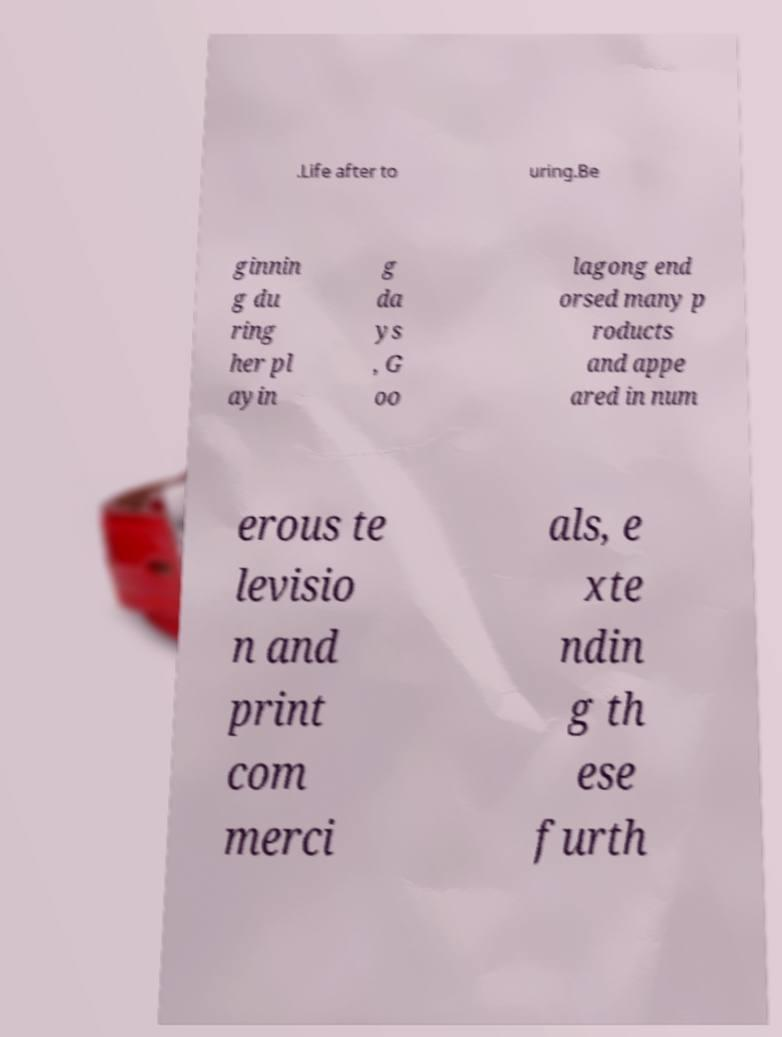What messages or text are displayed in this image? I need them in a readable, typed format. .Life after to uring.Be ginnin g du ring her pl ayin g da ys , G oo lagong end orsed many p roducts and appe ared in num erous te levisio n and print com merci als, e xte ndin g th ese furth 